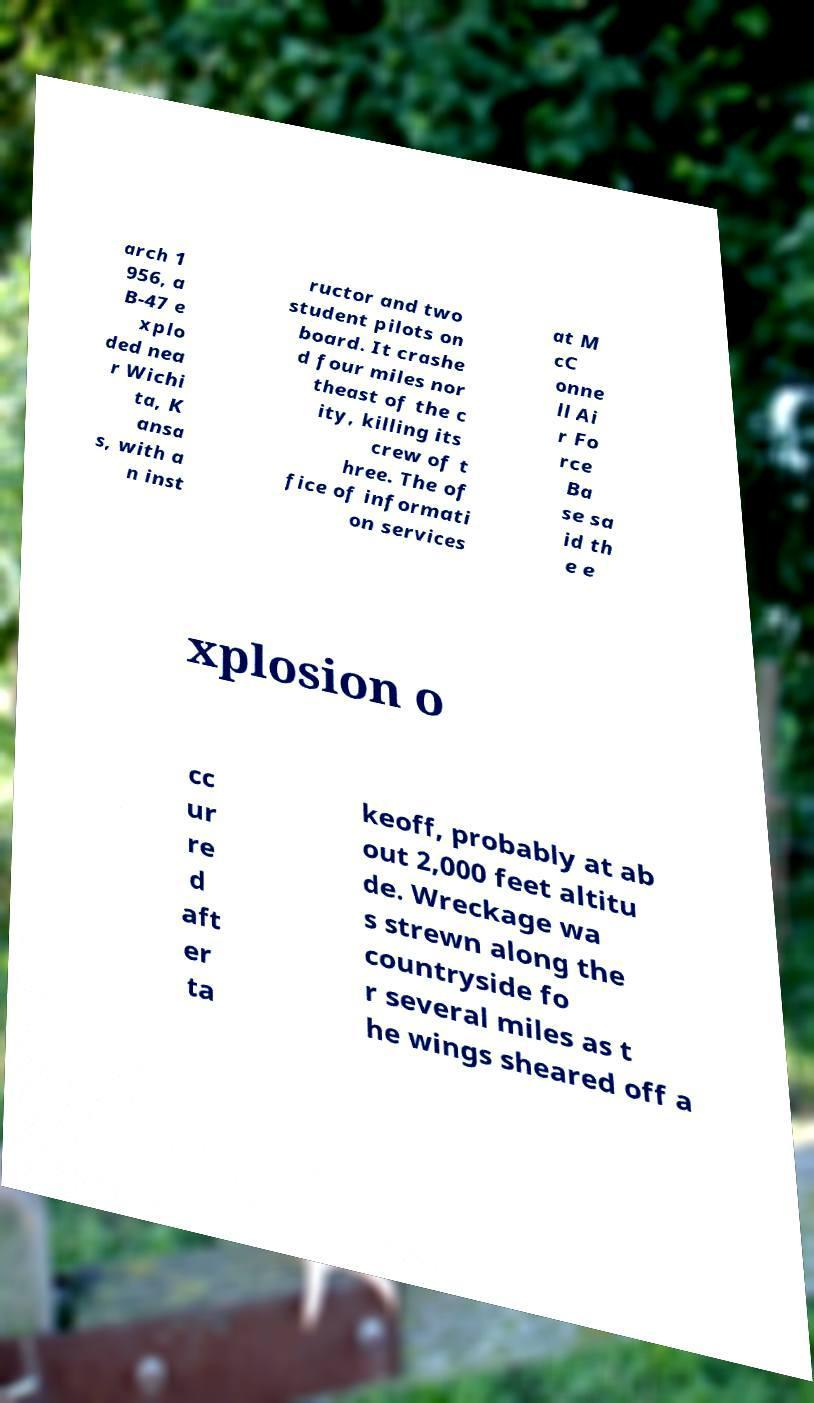Could you extract and type out the text from this image? arch 1 956, a B-47 e xplo ded nea r Wichi ta, K ansa s, with a n inst ructor and two student pilots on board. It crashe d four miles nor theast of the c ity, killing its crew of t hree. The of fice of informati on services at M cC onne ll Ai r Fo rce Ba se sa id th e e xplosion o cc ur re d aft er ta keoff, probably at ab out 2,000 feet altitu de. Wreckage wa s strewn along the countryside fo r several miles as t he wings sheared off a 